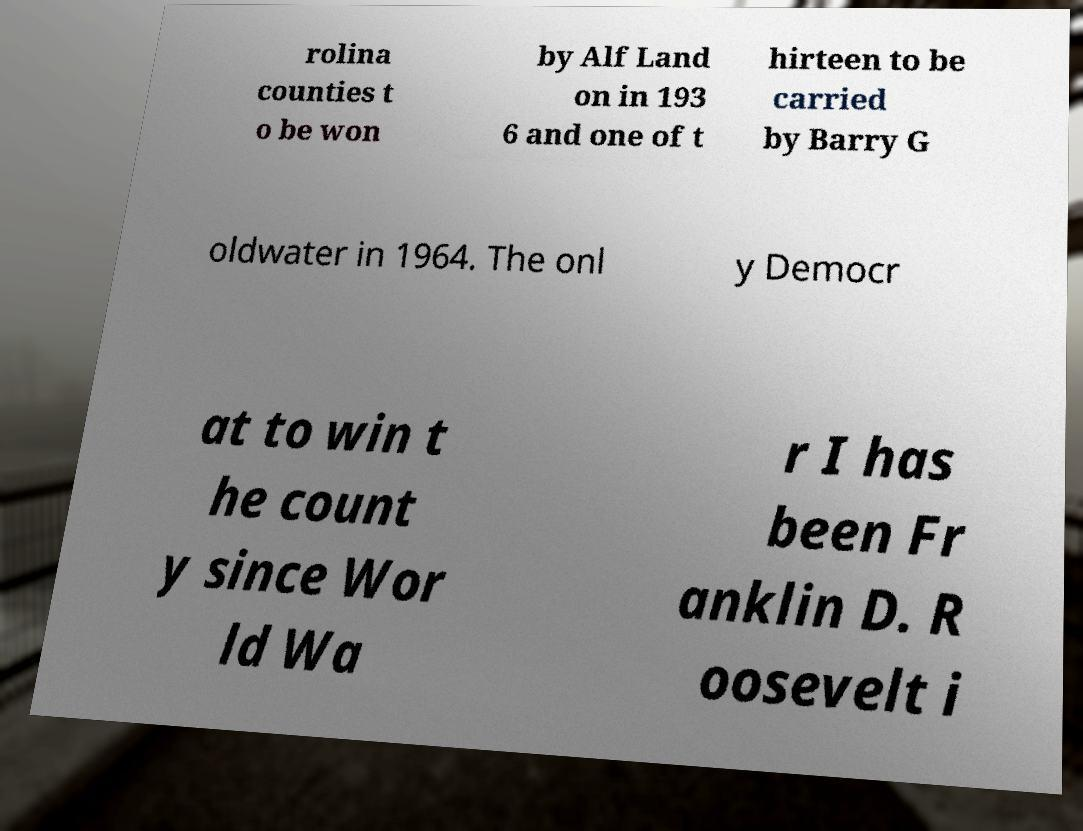Please identify and transcribe the text found in this image. rolina counties t o be won by Alf Land on in 193 6 and one of t hirteen to be carried by Barry G oldwater in 1964. The onl y Democr at to win t he count y since Wor ld Wa r I has been Fr anklin D. R oosevelt i 